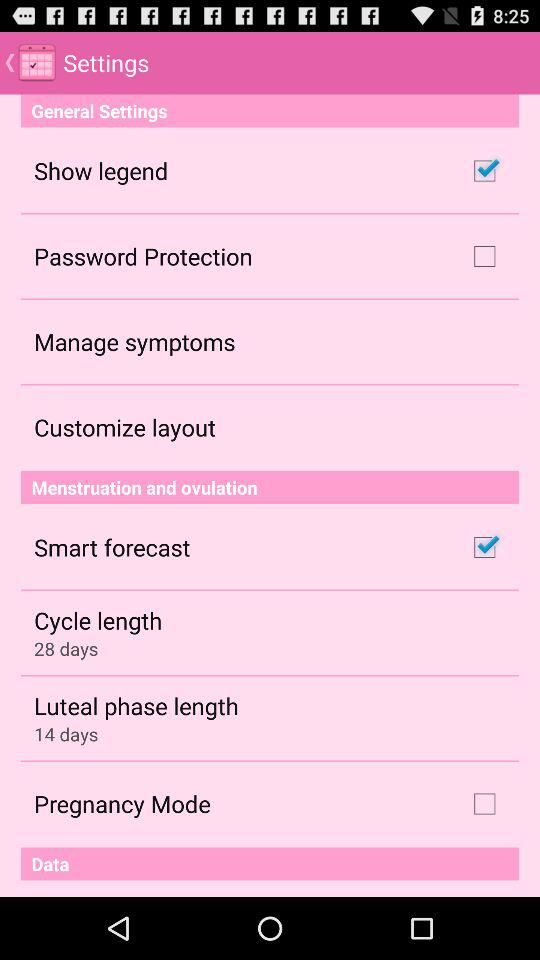What is the cycle length? The cycle length is 28 days. 